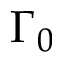<formula> <loc_0><loc_0><loc_500><loc_500>\Gamma _ { 0 }</formula> 